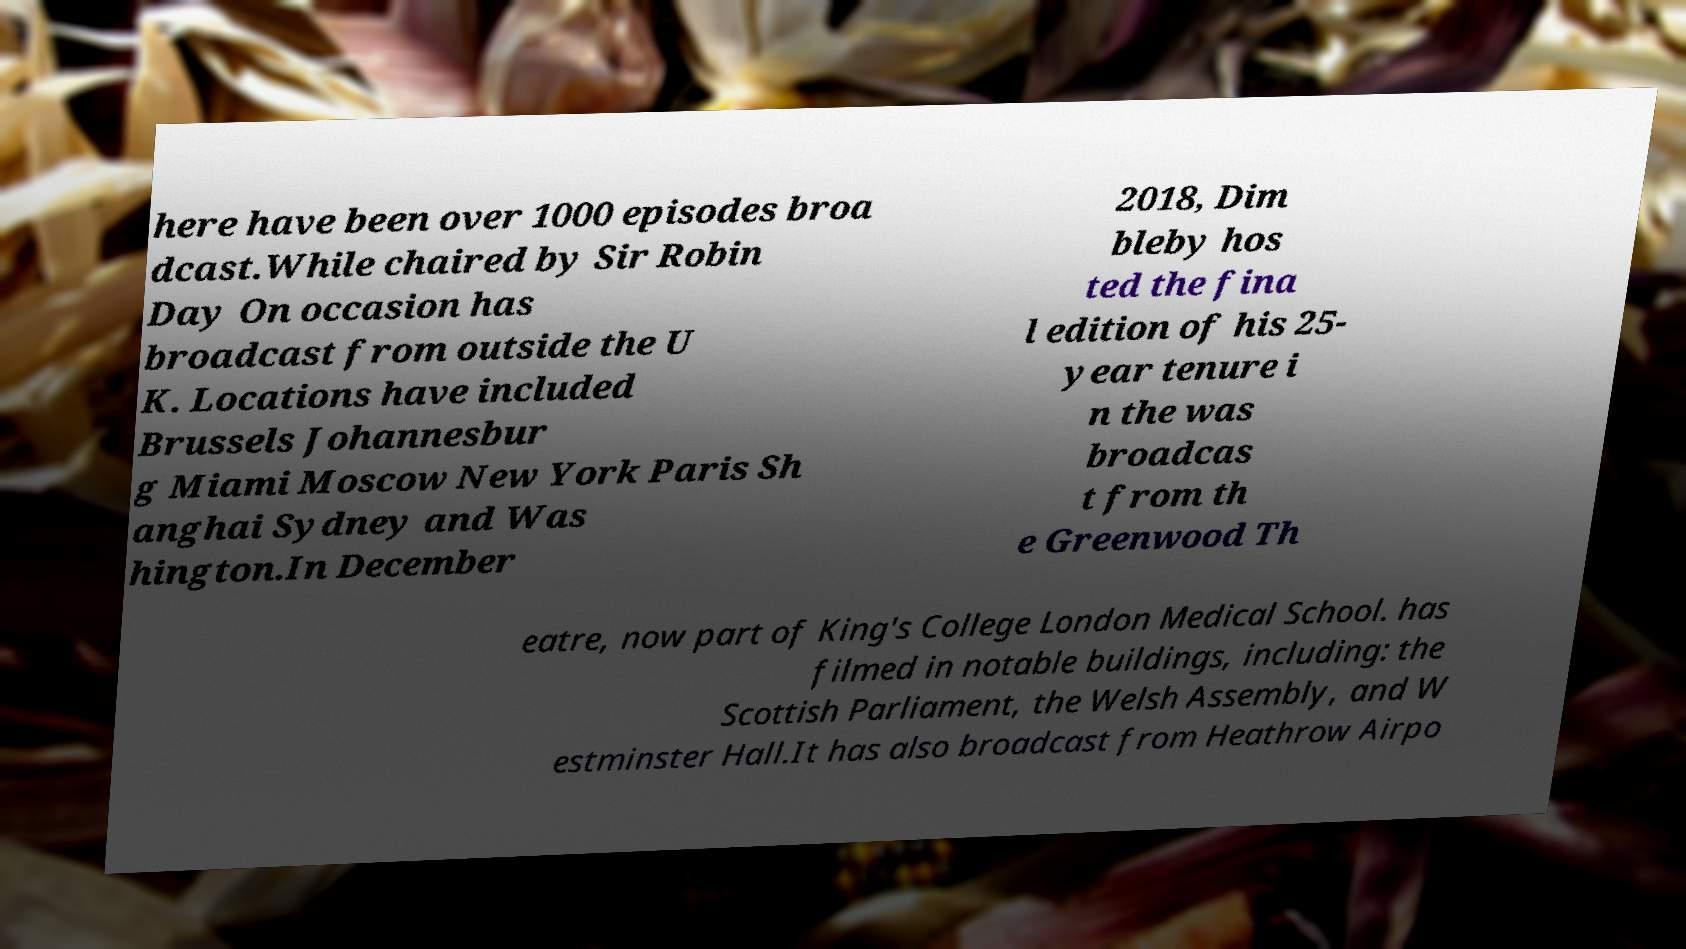Please identify and transcribe the text found in this image. here have been over 1000 episodes broa dcast.While chaired by Sir Robin Day On occasion has broadcast from outside the U K. Locations have included Brussels Johannesbur g Miami Moscow New York Paris Sh anghai Sydney and Was hington.In December 2018, Dim bleby hos ted the fina l edition of his 25- year tenure i n the was broadcas t from th e Greenwood Th eatre, now part of King's College London Medical School. has filmed in notable buildings, including: the Scottish Parliament, the Welsh Assembly, and W estminster Hall.It has also broadcast from Heathrow Airpo 